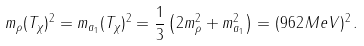Convert formula to latex. <formula><loc_0><loc_0><loc_500><loc_500>m _ { \rho } ( T _ { \chi } ) ^ { 2 } = m _ { a _ { 1 } } ( T _ { \chi } ) ^ { 2 } = \frac { 1 } { 3 } \left ( 2 m ^ { 2 } _ { \rho } + m ^ { 2 } _ { a _ { 1 } } \right ) = ( 9 6 2 \, M e V ) ^ { 2 } \, .</formula> 